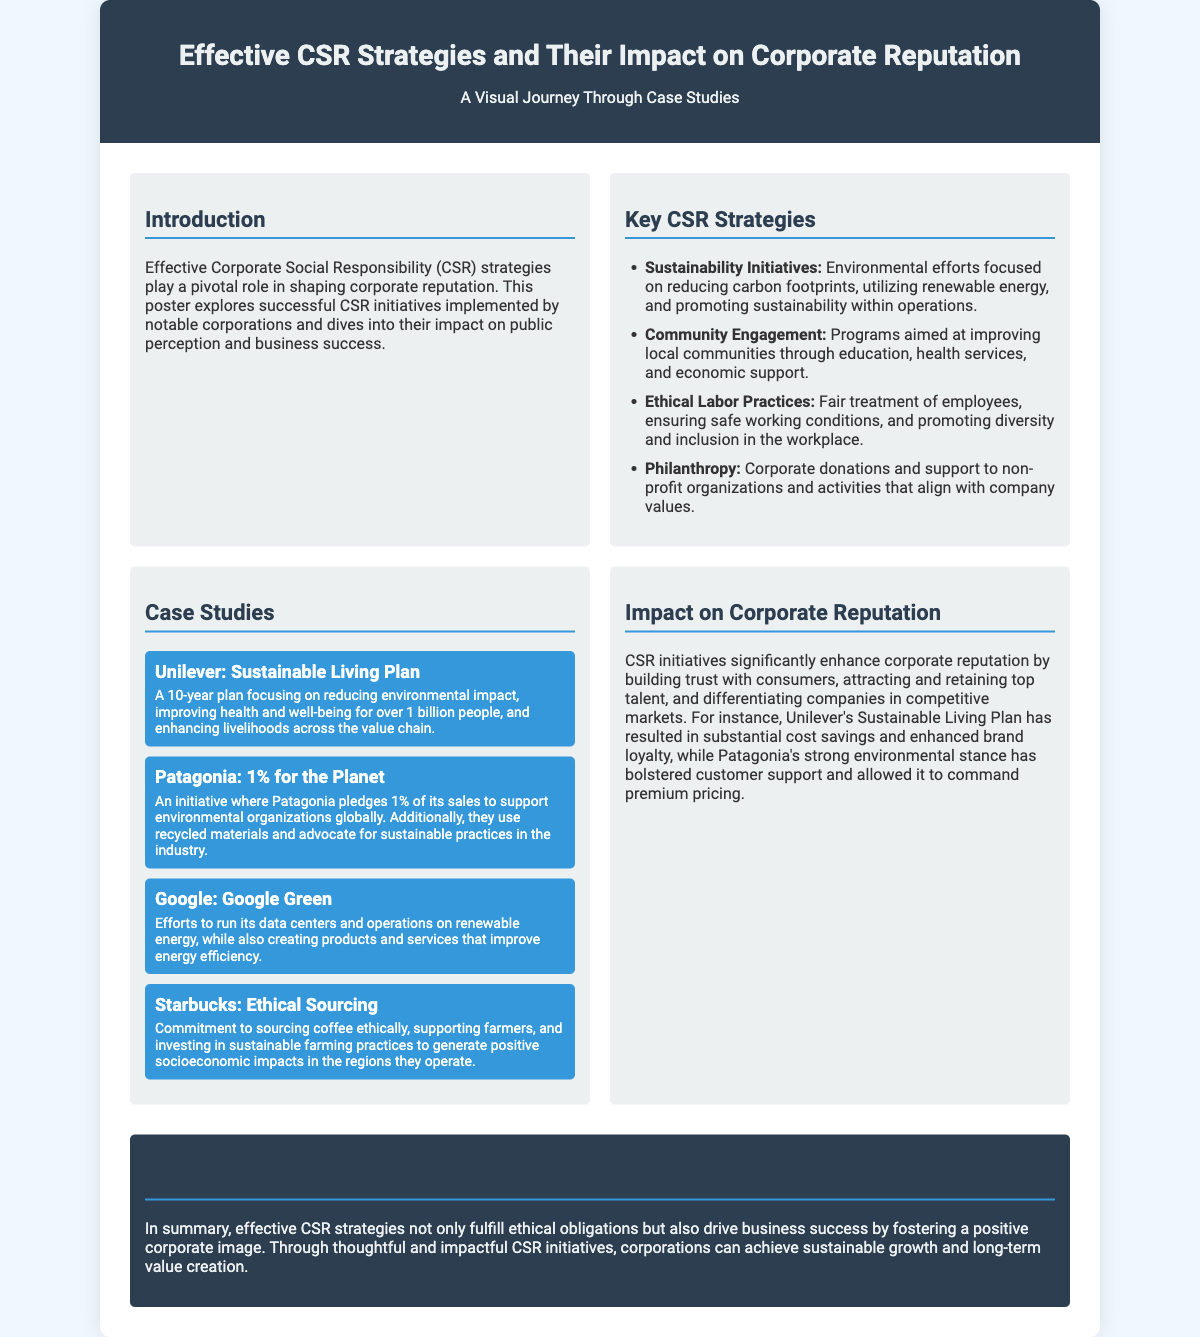what is the title of the poster? The title of the poster is prominently displayed at the top, indicating the main focus of the document.
Answer: Effective CSR Strategies and Their Impact on Corporate Reputation how many case studies are presented in the poster? The poster lists four specific case studies that illustrate effective CSR strategies.
Answer: 4 which company has a Sustainable Living Plan? The case study mentions a company that has a long-term plan for sustainability efforts.
Answer: Unilever what is one main goal of Patagonia's initiative? The case study highlights a specific commitment Patagonia has made towards environmental support.
Answer: 1% of its sales to support environmental organizations what impact do CSR initiatives have on corporate reputation? The poster discusses the general effects of CSR strategies on how corporations are perceived publicly.
Answer: Enhance corporate reputation which key CSR strategy focuses on fair treatment of employees? The poster identifies specific CSR strategies and one of them is aimed at workplace conditions and inclusivity.
Answer: Ethical Labor Practices what type of design elements are used in the poster? The poster's layout and color scheme are designed to enhance readability and visual appeal.
Answer: Header, sections, case studies, conclusion what is a significant outcome of Unilever's Sustainable Living Plan? The document mentions specific business outcomes related to Unilever's CSR efforts.
Answer: Substantial cost savings what is the concluding message of the poster? The conclusion summarizes the overall importance of CSR strategies for business success.
Answer: Effective CSR strategies drive business success 